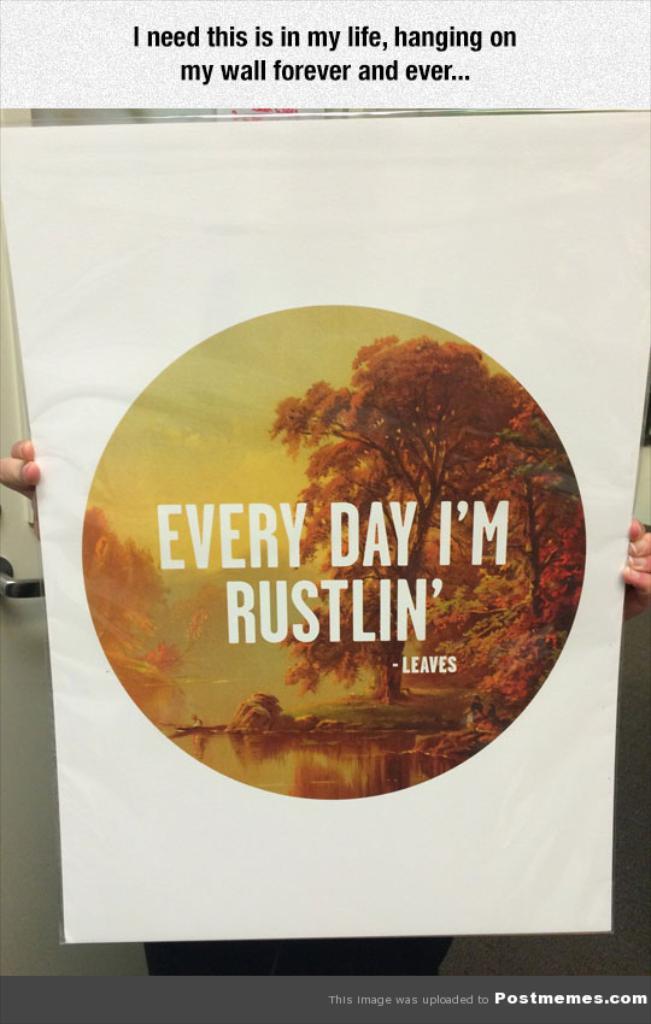Are leaves rustlin' every day?
Give a very brief answer. Yes. 